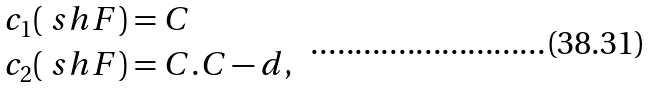Convert formula to latex. <formula><loc_0><loc_0><loc_500><loc_500>c _ { 1 } ( \ s h F ) & = C \\ c _ { 2 } ( \ s h F ) & = C . C - d ,</formula> 